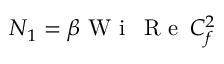<formula> <loc_0><loc_0><loc_500><loc_500>N _ { 1 } = \beta W i \, R e \, C _ { f } ^ { 2 }</formula> 